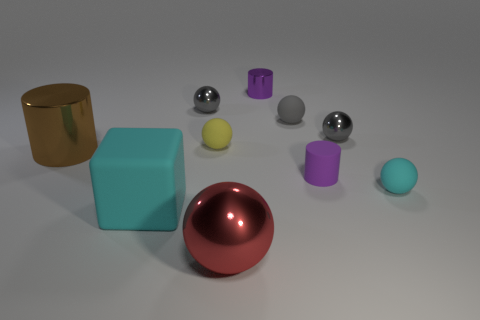How many purple metal things are the same size as the matte cube?
Give a very brief answer. 0. The tiny matte thing that is the same color as the matte cube is what shape?
Keep it short and to the point. Sphere. Do the shiny cylinder that is on the right side of the big cube and the matte cylinder that is to the right of the large red shiny thing have the same color?
Offer a terse response. Yes. What number of tiny gray shiny things are right of the big matte thing?
Make the answer very short. 2. What is the size of the ball that is the same color as the big rubber object?
Give a very brief answer. Small. Are there any cyan matte things of the same shape as the red metal thing?
Offer a terse response. Yes. What is the color of the rubber object that is the same size as the brown cylinder?
Make the answer very short. Cyan. Are there fewer tiny balls that are in front of the gray matte thing than things behind the red metal ball?
Offer a very short reply. Yes. There is a metallic object that is in front of the cyan block; does it have the same size as the yellow rubber object?
Make the answer very short. No. The big metallic thing that is to the right of the small yellow thing has what shape?
Offer a very short reply. Sphere. 